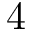<formula> <loc_0><loc_0><loc_500><loc_500>4</formula> 